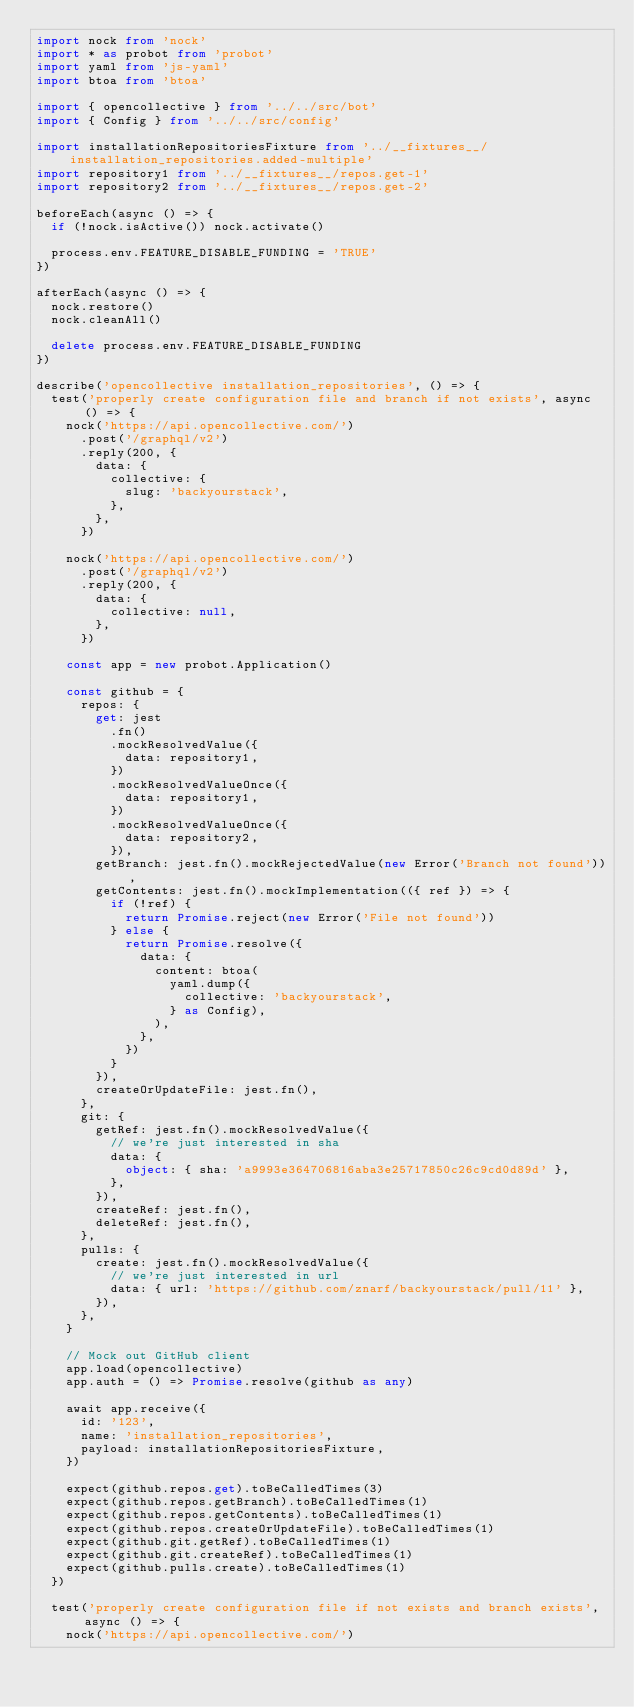<code> <loc_0><loc_0><loc_500><loc_500><_TypeScript_>import nock from 'nock'
import * as probot from 'probot'
import yaml from 'js-yaml'
import btoa from 'btoa'

import { opencollective } from '../../src/bot'
import { Config } from '../../src/config'

import installationRepositoriesFixture from '../__fixtures__/installation_repositories.added-multiple'
import repository1 from '../__fixtures__/repos.get-1'
import repository2 from '../__fixtures__/repos.get-2'

beforeEach(async () => {
  if (!nock.isActive()) nock.activate()

  process.env.FEATURE_DISABLE_FUNDING = 'TRUE'
})

afterEach(async () => {
  nock.restore()
  nock.cleanAll()

  delete process.env.FEATURE_DISABLE_FUNDING
})

describe('opencollective installation_repositories', () => {
  test('properly create configuration file and branch if not exists', async () => {
    nock('https://api.opencollective.com/')
      .post('/graphql/v2')
      .reply(200, {
        data: {
          collective: {
            slug: 'backyourstack',
          },
        },
      })

    nock('https://api.opencollective.com/')
      .post('/graphql/v2')
      .reply(200, {
        data: {
          collective: null,
        },
      })

    const app = new probot.Application()

    const github = {
      repos: {
        get: jest
          .fn()
          .mockResolvedValue({
            data: repository1,
          })
          .mockResolvedValueOnce({
            data: repository1,
          })
          .mockResolvedValueOnce({
            data: repository2,
          }),
        getBranch: jest.fn().mockRejectedValue(new Error('Branch not found')),
        getContents: jest.fn().mockImplementation(({ ref }) => {
          if (!ref) {
            return Promise.reject(new Error('File not found'))
          } else {
            return Promise.resolve({
              data: {
                content: btoa(
                  yaml.dump({
                    collective: 'backyourstack',
                  } as Config),
                ),
              },
            })
          }
        }),
        createOrUpdateFile: jest.fn(),
      },
      git: {
        getRef: jest.fn().mockResolvedValue({
          // we're just interested in sha
          data: {
            object: { sha: 'a9993e364706816aba3e25717850c26c9cd0d89d' },
          },
        }),
        createRef: jest.fn(),
        deleteRef: jest.fn(),
      },
      pulls: {
        create: jest.fn().mockResolvedValue({
          // we're just interested in url
          data: { url: 'https://github.com/znarf/backyourstack/pull/11' },
        }),
      },
    }

    // Mock out GitHub client
    app.load(opencollective)
    app.auth = () => Promise.resolve(github as any)

    await app.receive({
      id: '123',
      name: 'installation_repositories',
      payload: installationRepositoriesFixture,
    })

    expect(github.repos.get).toBeCalledTimes(3)
    expect(github.repos.getBranch).toBeCalledTimes(1)
    expect(github.repos.getContents).toBeCalledTimes(1)
    expect(github.repos.createOrUpdateFile).toBeCalledTimes(1)
    expect(github.git.getRef).toBeCalledTimes(1)
    expect(github.git.createRef).toBeCalledTimes(1)
    expect(github.pulls.create).toBeCalledTimes(1)
  })

  test('properly create configuration file if not exists and branch exists', async () => {
    nock('https://api.opencollective.com/')</code> 